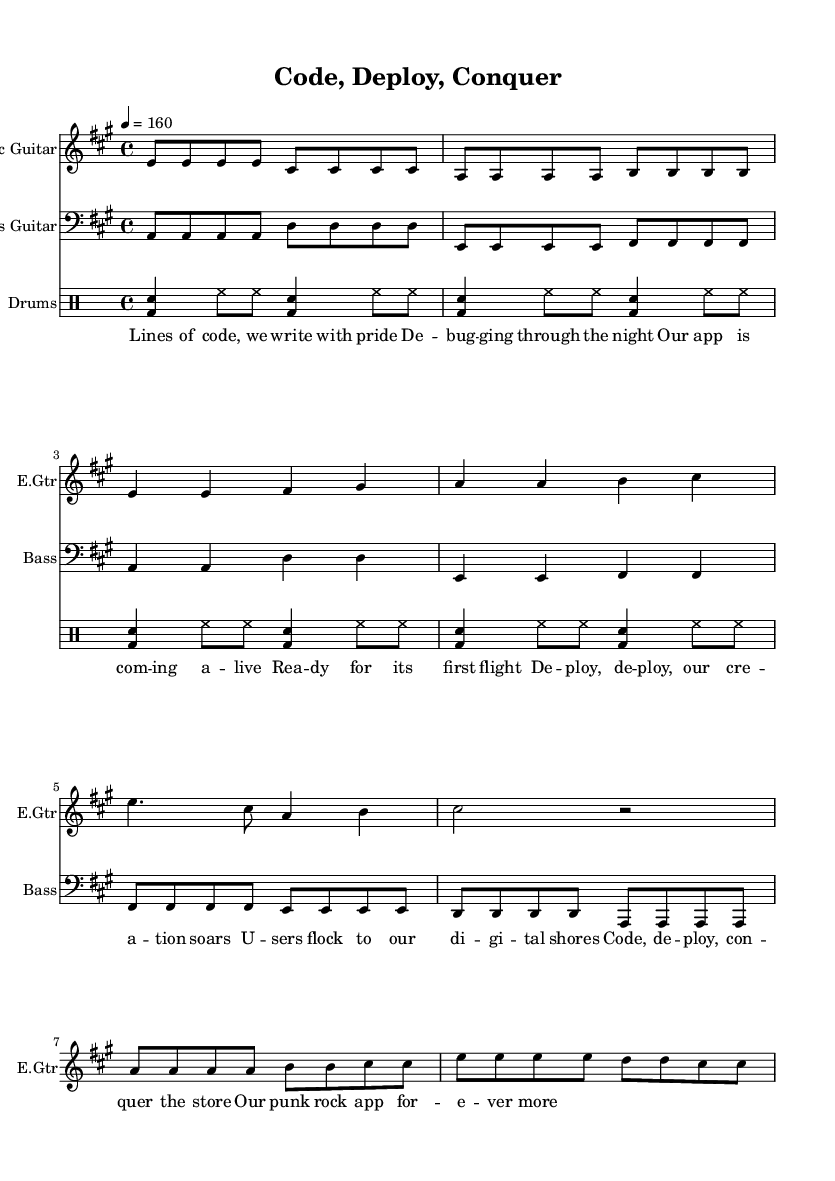What is the key signature of this music? The key signature is A major, which has three sharps (F#, C#, and G#). It can be identified at the beginning of the score, indicated by the sharp symbols.
Answer: A major What is the time signature of this music? The time signature is 4/4, which means there are four beats in a measure and the quarter note receives one beat. This is typically indicated at the start of the music, showing how the measures are structured.
Answer: 4/4 What is the tempo marking for this piece? The tempo marking is 160 beats per minute, indicated in the score after the time signature. It shows the pace at which the piece should be played, specifically stating that quarter notes should be played at a rate of 160 per minute.
Answer: 160 How many measures are in the verse section? There are four measures in the verse section of the song, as seen in the notation where the melody for the verse repeats four times in that specific format without any interruptions.
Answer: Four What instrument plays the main melody? The Electric Guitar plays the main melody throughout the piece, which can be identified as the top staff in the score. This instrument typically carries the primary thematic material in punk music.
Answer: Electric Guitar What is the rhythmic pattern used in the drum section? The rhythmic pattern in the drum section consists of a bass drum and snare alternating with hi-hat cymbals, creating a driving punk rock feel. It is a typical pattern in punk music, characterized by its energy and intensity.
Answer: Bass and snare with hi-hats What is the overarching theme of the lyrics? The overarching theme of the lyrics is about successfully launching an app and the pride associated with coding and deploying it. The lyrics celebrate the experience of bringing a digital creation to life, resonating with the punk ethos of doing things passionately and authentically.
Answer: Success in app launching 